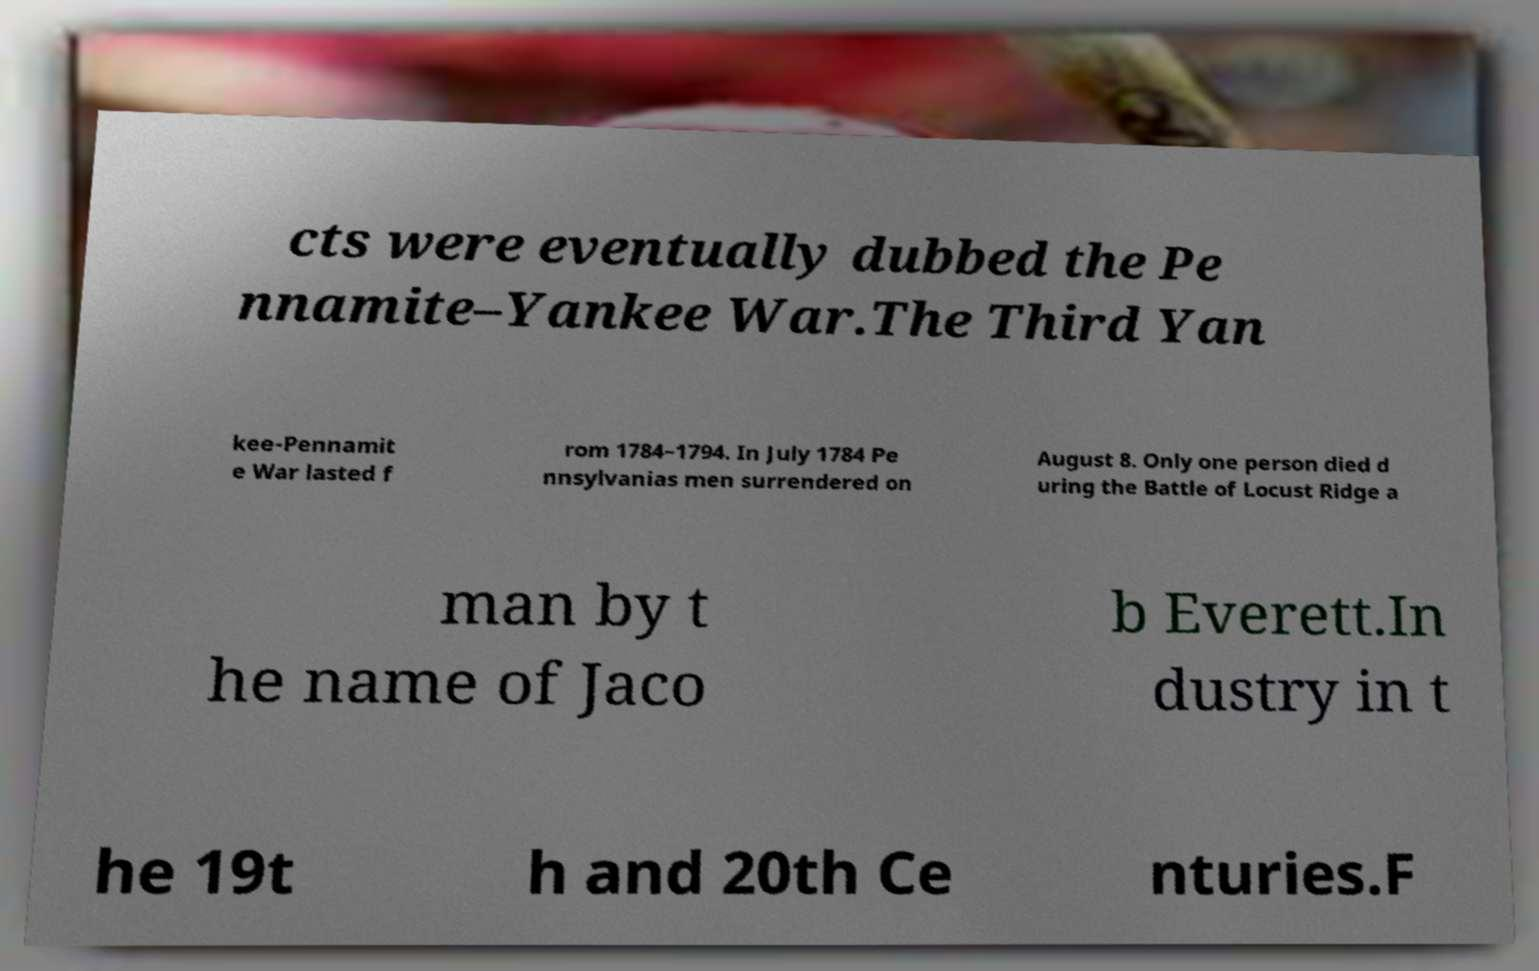What messages or text are displayed in this image? I need them in a readable, typed format. cts were eventually dubbed the Pe nnamite–Yankee War.The Third Yan kee-Pennamit e War lasted f rom 1784–1794. In July 1784 Pe nnsylvanias men surrendered on August 8. Only one person died d uring the Battle of Locust Ridge a man by t he name of Jaco b Everett.In dustry in t he 19t h and 20th Ce nturies.F 